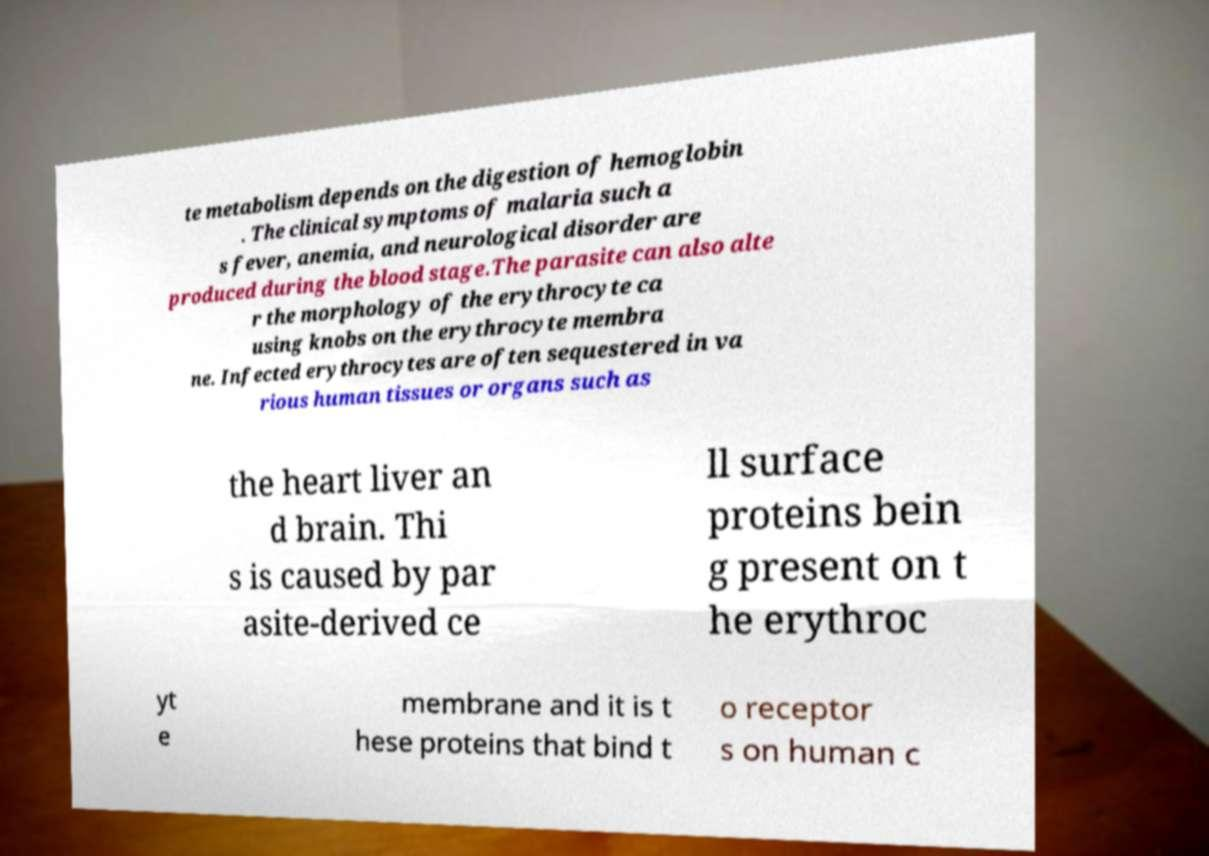Can you accurately transcribe the text from the provided image for me? te metabolism depends on the digestion of hemoglobin . The clinical symptoms of malaria such a s fever, anemia, and neurological disorder are produced during the blood stage.The parasite can also alte r the morphology of the erythrocyte ca using knobs on the erythrocyte membra ne. Infected erythrocytes are often sequestered in va rious human tissues or organs such as the heart liver an d brain. Thi s is caused by par asite-derived ce ll surface proteins bein g present on t he erythroc yt e membrane and it is t hese proteins that bind t o receptor s on human c 